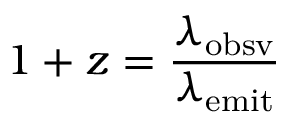<formula> <loc_0><loc_0><loc_500><loc_500>1 + z = { \frac { \lambda _ { o b s v } } { \lambda _ { e m i t } } }</formula> 